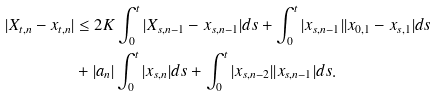<formula> <loc_0><loc_0><loc_500><loc_500>| X _ { t , n } - x _ { t , n } | & \leq 2 K \int _ { 0 } ^ { t } | X _ { s , n - 1 } - x _ { s , n - 1 } | d s + \int _ { 0 } ^ { t } | x _ { s , n - 1 } | | x _ { 0 , 1 } - x _ { s , 1 } | d s \\ & + | a _ { n } | \int _ { 0 } ^ { t } | x _ { s , n } | d s + \int _ { 0 } ^ { t } | x _ { s , n - 2 } | | x _ { s , n - 1 } | d s .</formula> 